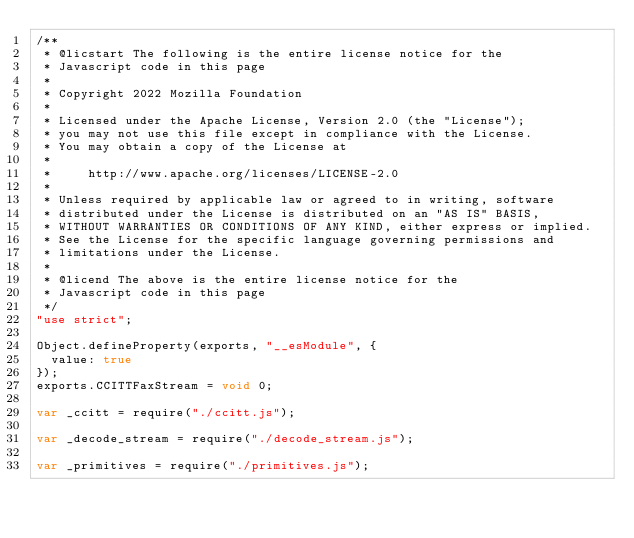Convert code to text. <code><loc_0><loc_0><loc_500><loc_500><_JavaScript_>/**
 * @licstart The following is the entire license notice for the
 * Javascript code in this page
 *
 * Copyright 2022 Mozilla Foundation
 *
 * Licensed under the Apache License, Version 2.0 (the "License");
 * you may not use this file except in compliance with the License.
 * You may obtain a copy of the License at
 *
 *     http://www.apache.org/licenses/LICENSE-2.0
 *
 * Unless required by applicable law or agreed to in writing, software
 * distributed under the License is distributed on an "AS IS" BASIS,
 * WITHOUT WARRANTIES OR CONDITIONS OF ANY KIND, either express or implied.
 * See the License for the specific language governing permissions and
 * limitations under the License.
 *
 * @licend The above is the entire license notice for the
 * Javascript code in this page
 */
"use strict";

Object.defineProperty(exports, "__esModule", {
  value: true
});
exports.CCITTFaxStream = void 0;

var _ccitt = require("./ccitt.js");

var _decode_stream = require("./decode_stream.js");

var _primitives = require("./primitives.js");
</code> 